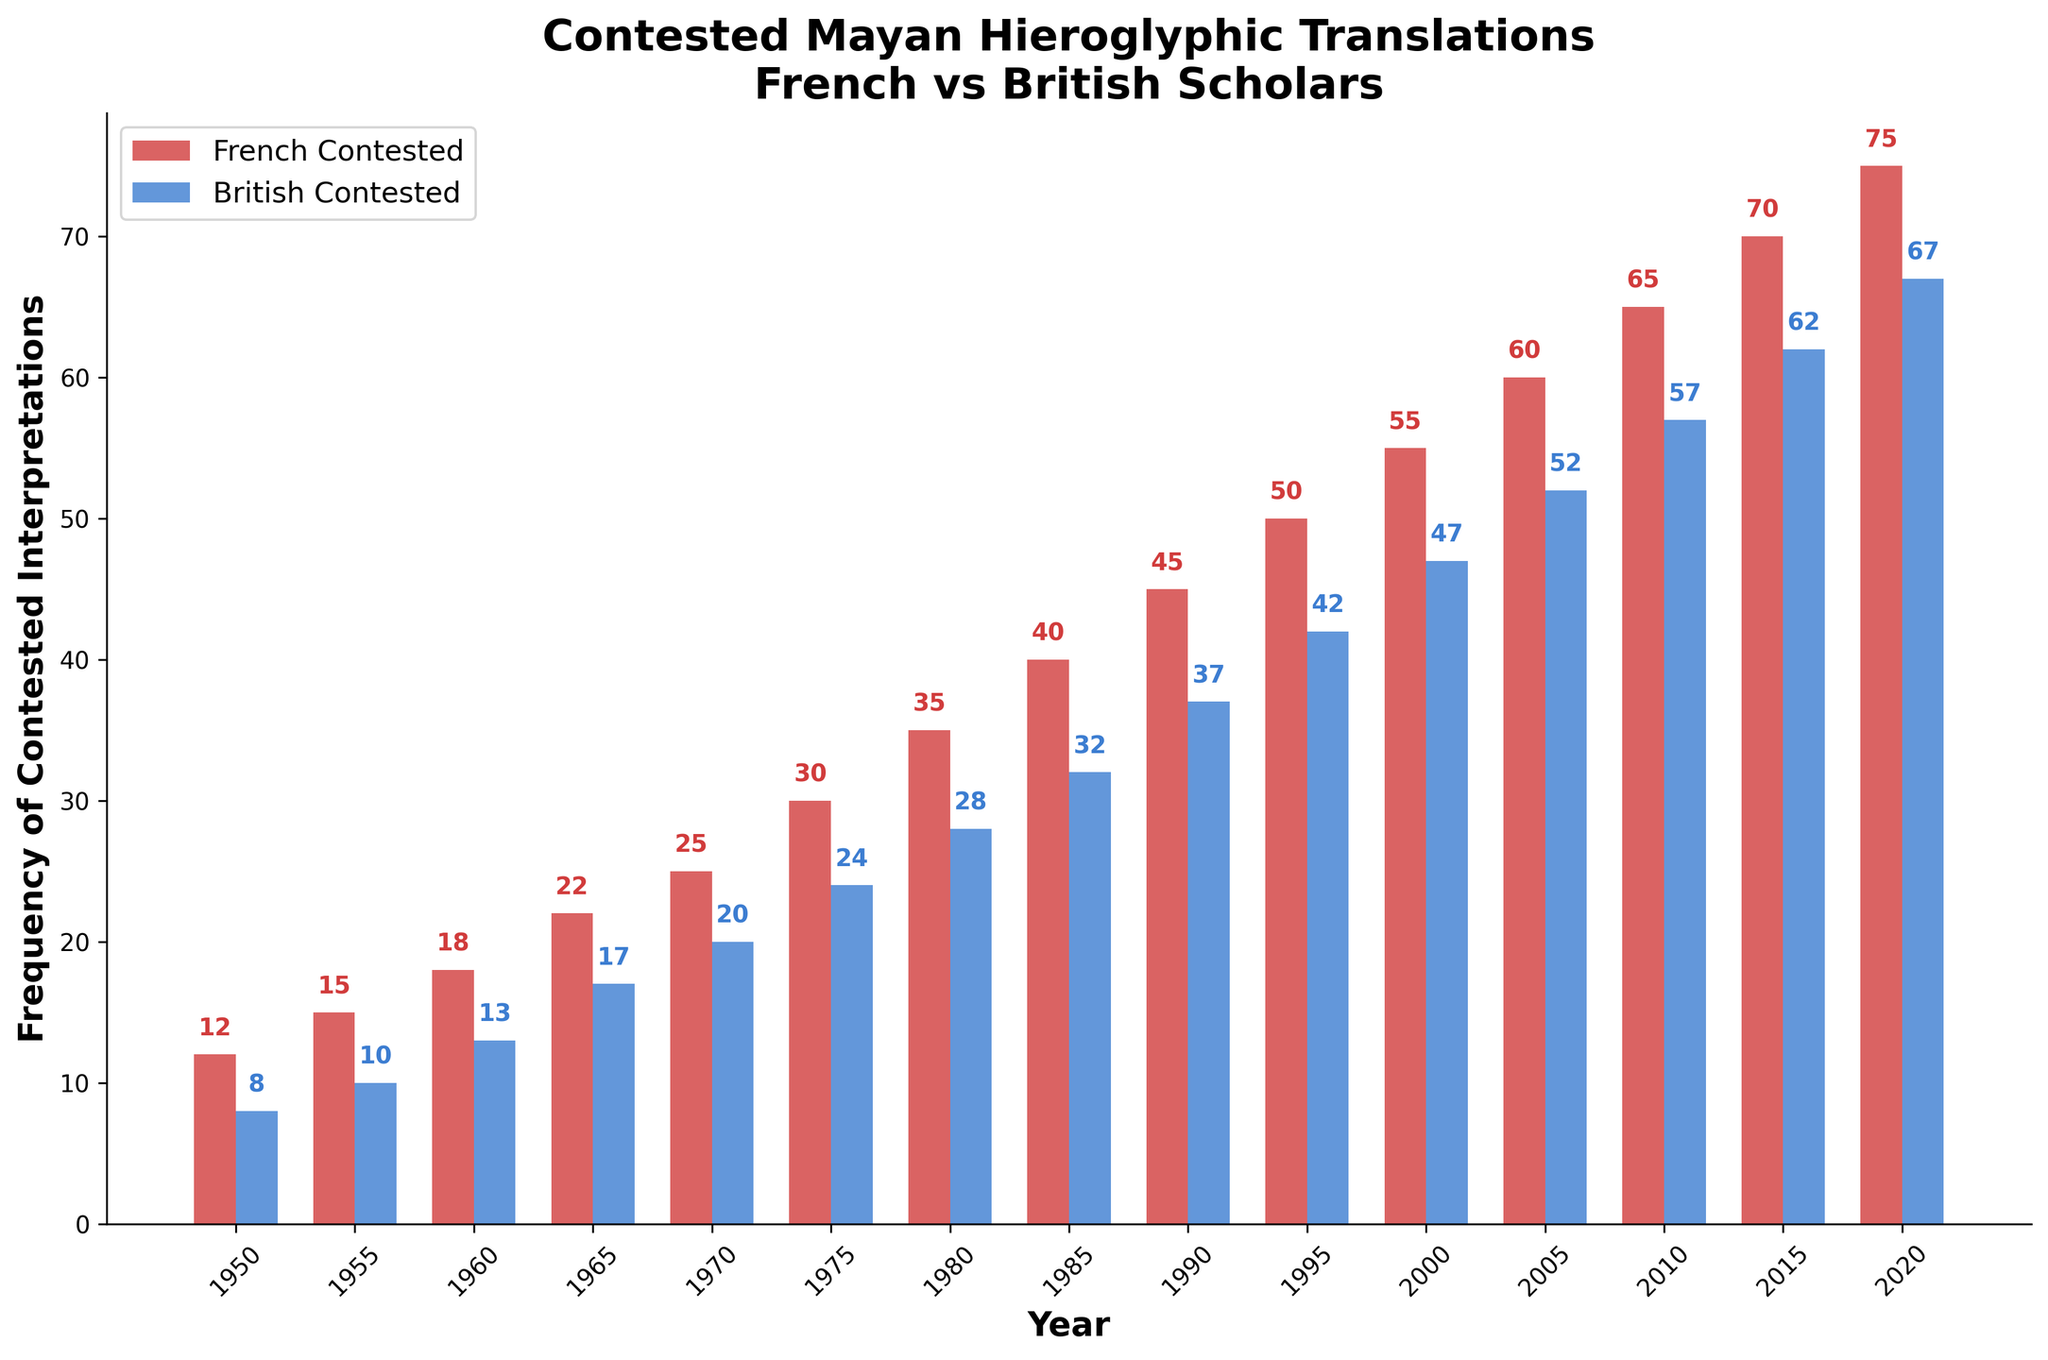Which year had the highest frequency of contested interpretations by French scholars? The bar representing the French Contested interpretations is highest in 2020, with a value of 75.
Answer: 2020 Compare the frequency of contested interpretations between French and British scholars in 1980. In 1980, the French scholars had 35 contested interpretations, while the British scholars had 28. Therefore, French scholars had 7 more contested interpretations in that year.
Answer: 7 What is the difference in the frequency of contested interpretations between French and British scholars in 2000? In 2000, French scholars had 55 contested interpretations and British scholars had 47. The difference is 55 - 47 = 8.
Answer: 8 What is the average frequency of contested interpretations by French scholars from 1950 to 2020? Sum all the values for French Contested from 1950 to 2020 and divide by the number of data points: (12 + 15 + 18 + 22 + 25 + 30 + 35 + 40 + 45 + 50 + 55 + 60 + 65 + 70 + 75) / 15 = 41.6667.
Answer: 41.67 How many more contested interpretations did French scholars have compared to British scholars in 1995? In 1995, French scholars had 50 contested interpretations and British scholars had 42. The difference is 50 - 42 = 8.
Answer: 8 Which year shows the smallest difference in contested interpretations between French and British scholars? Analyze the difference in contested interpretations for each year. The year with the smallest difference is 1950 with a difference of 4 (12 - 8 = 4).
Answer: 1950 Describe the trend in the frequency of contested interpretations by British scholars from 1950 to 2020. The frequency of contested interpretations by British scholars shows an upward trend from 1950 (8) to 2020 (67).
Answer: Upward trend In which year did French scholars first exceed 50 contested interpretations? Looking at the values for the French Contested interpretations, the first year when it exceeds 50 is 1995 with 50 contested interpretations.
Answer: 1995 What is the total frequency of contested interpretations by French scholars in the decade 1980-1990? Sum the values for French Contested from 1980 to 1990: 35 + 40 + 45 = 120.
Answer: 120 